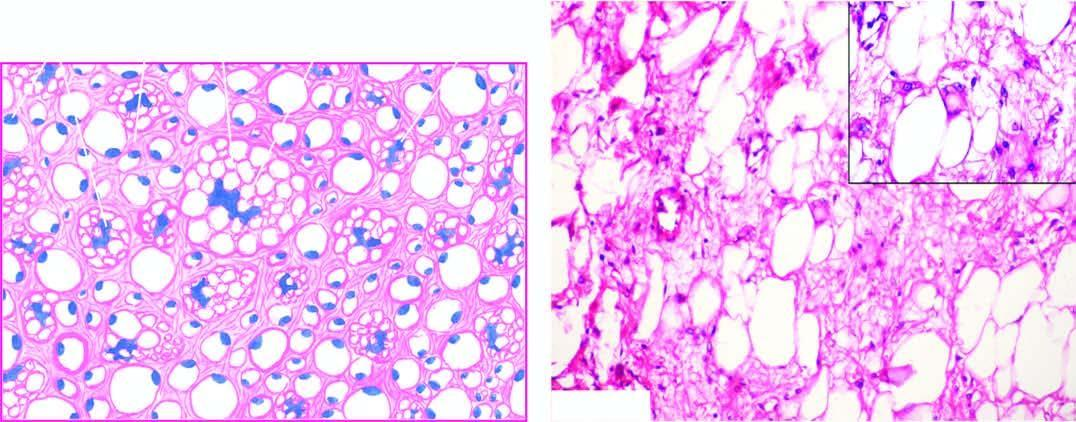does the tumour show characteristic, univacuolated and multivacuolated lipoblasts with bizarre nuclei?
Answer the question using a single word or phrase. Yes 